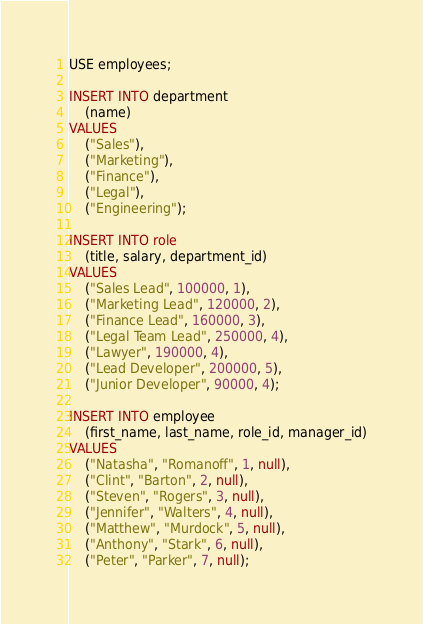<code> <loc_0><loc_0><loc_500><loc_500><_SQL_>USE employees;

INSERT INTO department
    (name)
VALUES
    ("Sales"),
    ("Marketing"),
    ("Finance"),
    ("Legal"),
    ("Engineering");

INSERT INTO role
    (title, salary, department_id)
VALUES
    ("Sales Lead", 100000, 1),
    ("Marketing Lead", 120000, 2),
    ("Finance Lead", 160000, 3),
    ("Legal Team Lead", 250000, 4),
    ("Lawyer", 190000, 4),
    ("Lead Developer", 200000, 5),
    ("Junior Developer", 90000, 4);

INSERT INTO employee
    (first_name, last_name, role_id, manager_id)
VALUES
    ("Natasha", "Romanoff", 1, null),
    ("Clint", "Barton", 2, null),
    ("Steven", "Rogers", 3, null),
    ("Jennifer", "Walters", 4, null),
    ("Matthew", "Murdock", 5, null),
    ("Anthony", "Stark", 6, null),
    ("Peter", "Parker", 7, null);
</code> 